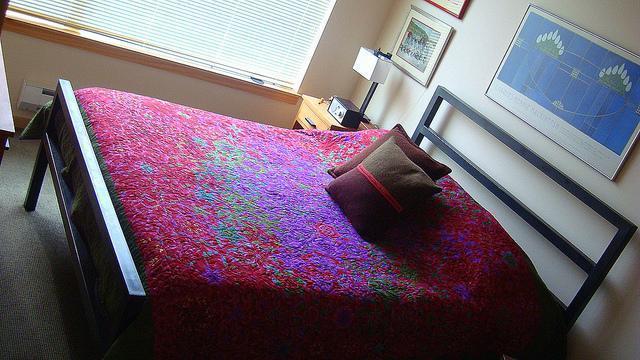How many pillows are on the bed?
Give a very brief answer. 2. How many beds are in the photo?
Give a very brief answer. 1. How many people in either image are playing tennis?
Give a very brief answer. 0. 